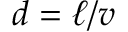<formula> <loc_0><loc_0><loc_500><loc_500>d = \ell / v</formula> 